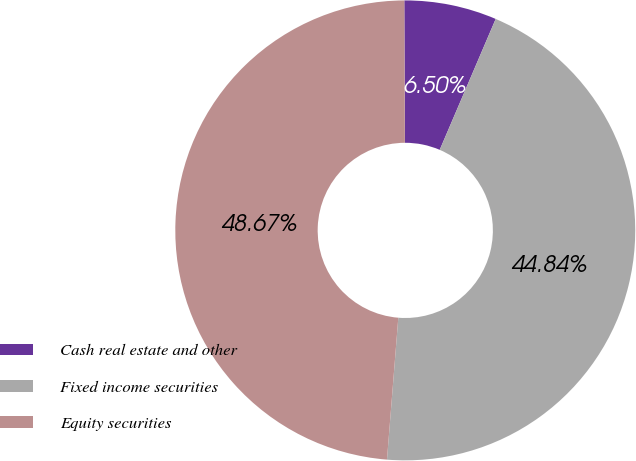Convert chart. <chart><loc_0><loc_0><loc_500><loc_500><pie_chart><fcel>Cash real estate and other<fcel>Fixed income securities<fcel>Equity securities<nl><fcel>6.5%<fcel>44.84%<fcel>48.67%<nl></chart> 